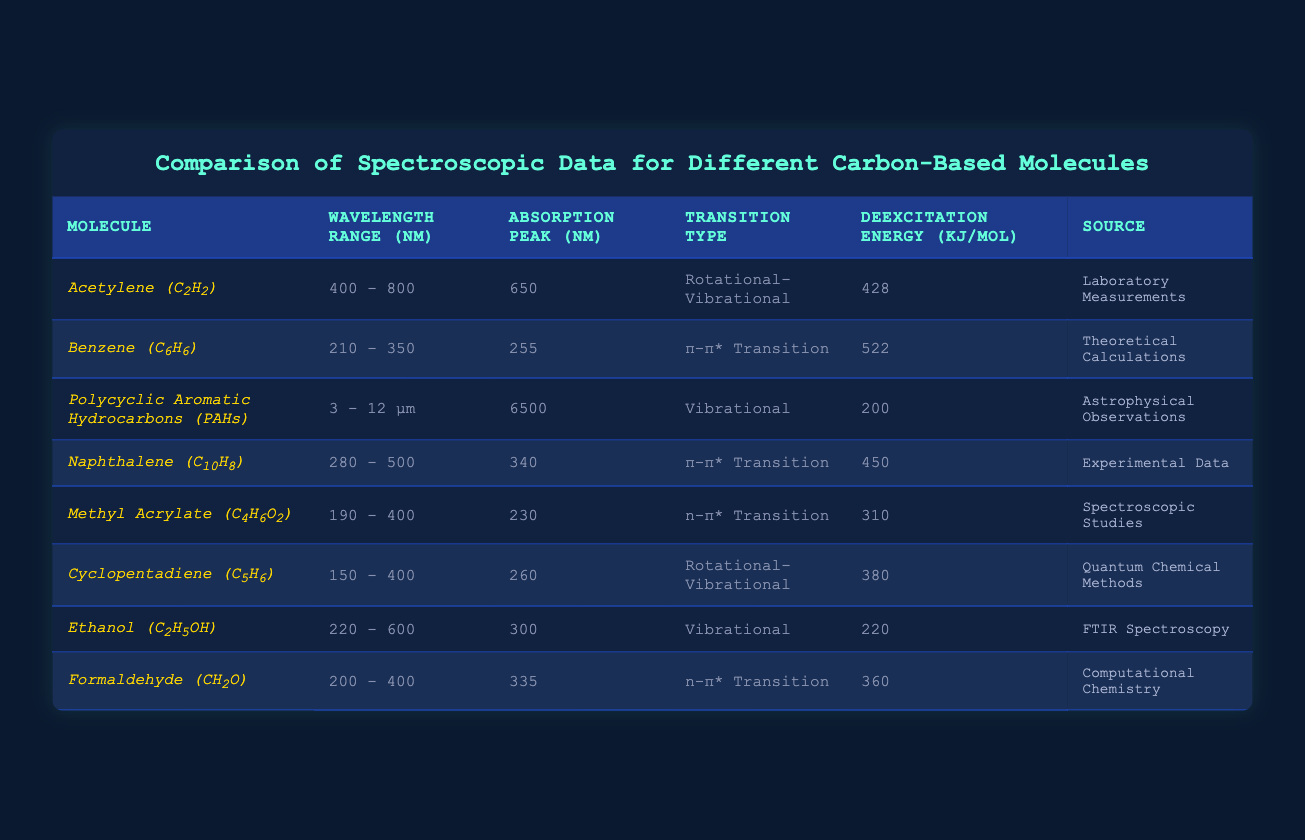What is the absorption peak wavelength of Benzene? The absorption peak wavelength for Benzene is listed in the table under the "Absorption Peak (nm)" column, which shows a value of 255 nm.
Answer: 255 nm Which molecule has the highest deexcitation energy? By inspecting the "Deexcitation Energy (kJ/mol)" column, Benzene has the highest value at 522 kJ/mol.
Answer: Benzene (C6H6) Is the wavelength range of Cyclopentadiene greater than that of Methyl Acrylate? The "Wavelength Range (nm)" for Cyclopentadiene is from 150 to 400 nm, while Methyl Acrylate ranges from 190 to 400 nm. Since the range does not exceed, the answer is no.
Answer: No Calculate the average deexcitation energy of the molecules with n-π* transitions. The molecules with n-π* transitions are Methyl Acrylate (310 kJ/mol) and Formaldehyde (360 kJ/mol). Adding these gives 670 kJ/mol, and there are 2 molecules, so the average is 670/2 = 335 kJ/mol.
Answer: 335 kJ/mol Which molecule exhibits a vibrational transition type and what is its absorption peak? Examining the table reveals two molecules with a vibrational transition: Polycyclic Aromatic Hydrocarbons (PAHs) at 6500 nm and Ethanol at 300 nm.
Answer: PAHs at 6500 nm and Ethanol at 300 nm Are all molecules listed sourced from experimental data? The table lists different sources for each molecule, including "Laboratory Measurements," "Theoretical Calculations," and others. Since not all are from experimental data, the answer is no.
Answer: No What is the difference in absorption peak wavelength between Acetylene and Naphthalene? Acetylene has an absorption peak of 650 nm, while Naphthalene has 340 nm. The difference is calculated as 650 - 340 = 310 nm.
Answer: 310 nm Which molecule has the shortest wavelength range? By comparing the "Wavelength Range (nm)" values, Methyl Acrylate has the shortest range of 190 - 400 nm, which is 210 nm.
Answer: Methyl Acrylate (C4H6O2) Is the absorption peak for Polycyclic Aromatic Hydrocarbons higher or lower than 3000 nm? Polycyclic Aromatic Hydrocarbons have an absorption peak at 6500 nm, which is higher than 3000 nm.
Answer: Higher What is the combined deexcitation energy of Acetylene and Cyclopentadiene? The deexcitation energy for Acetylene is 428 kJ/mol and for Cyclopentadiene is 380 kJ/mol. Adding these gives 428 + 380 = 808 kJ/mol.
Answer: 808 kJ/mol 